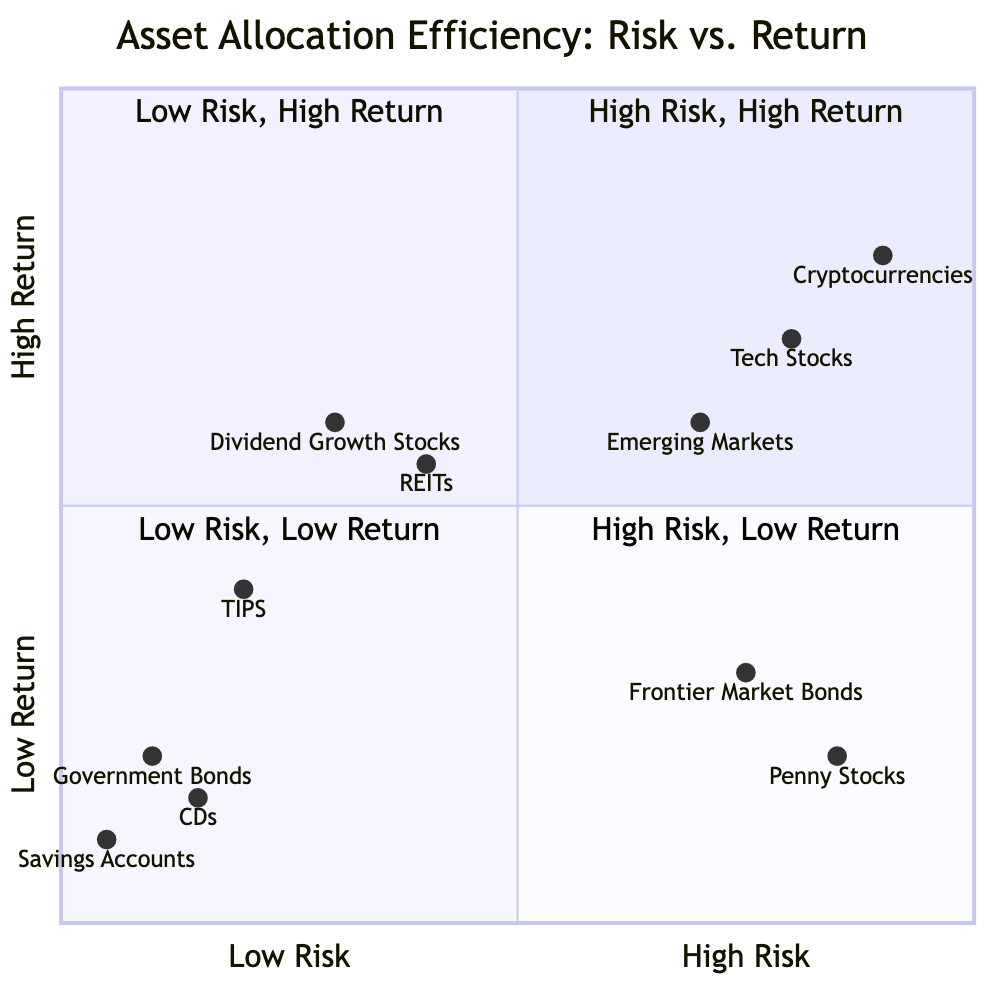What assets are categorized under High Risk, High Return? The quadrant labeled "High Risk, High Return" includes Tech Stocks, Cryptocurrencies, and Emerging Markets.
Answer: Tech Stocks, Cryptocurrencies, Emerging Markets What is the example of a Low Risk, Low Return asset? To answer this, we refer to the quadrant "Low Risk, Low Return," which lists assets such as Government Bonds, Savings Accounts, and Certificates of Deposit (CD).
Answer: Government Bonds Which asset has the highest return expectation within the High Risk, High Return quadrant? We compare the assets in this quadrant: Tech Stocks, Cryptocurrencies, and Emerging Markets. Cryptocurrencies show the highest return expectation at 0.8, making it the asset with the highest return here.
Answer: Cryptocurrencies How many assets are listed in the Low Risk, High Return quadrant? This quadrant includes one asset group: Dividend Growth Stocks, REITs, and TIPS—totaling three assets in this category.
Answer: 3 What is the risk value of Emerging Markets? To find this information, we check the risk value assigned to Emerging Markets, which is indicated as 0.7 in the diagram.
Answer: 0.7 Which quadrant contains Penny Stocks? Penny Stocks fall under the quadrant labeled "High Risk, Low Return," based on their classification in the chart.
Answer: High Risk, Low Return What do Treasury Inflation-Protected Securities (TIPS) return? The example for TIPS in the Low Risk, High Return quadrant states its rate of return as ranging between 1 to 3 percent.
Answer: 1-3% Which asset category has the lowest risk among all listed assets? When examining all quadrants, Government Bonds in the Low Risk, Low Return section are shown with the lowest risk value of 0.1.
Answer: Government Bonds What is the highest risk value represented in the diagram? The asset with the highest risk value listed is Cryptocurrencies, noted in the high-risk quadrant with a value of 0.9.
Answer: 0.9 